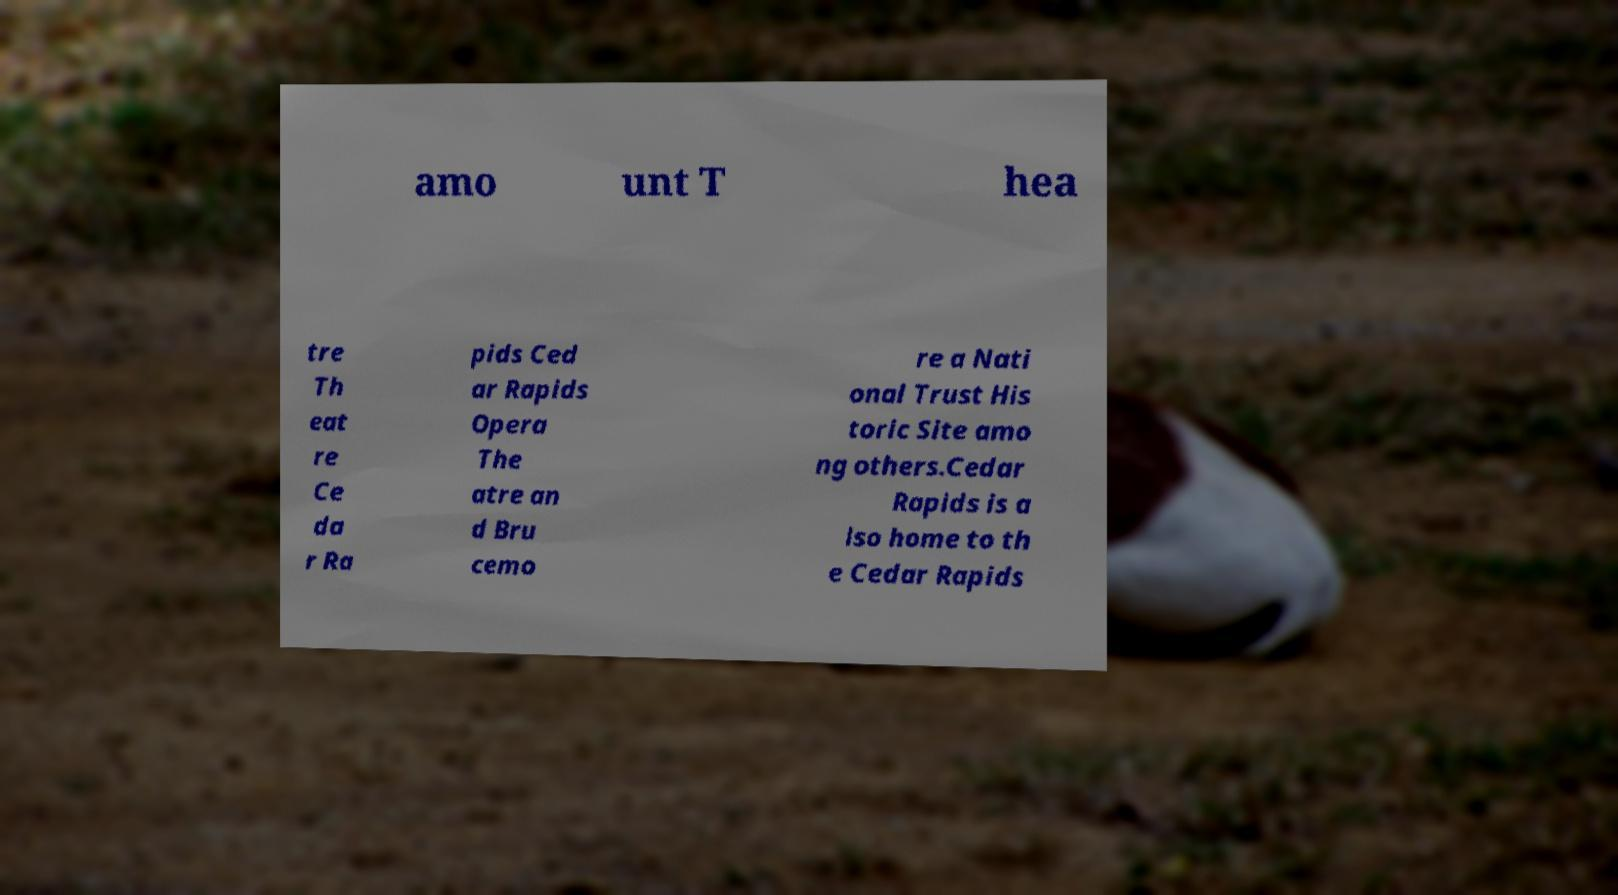What messages or text are displayed in this image? I need them in a readable, typed format. amo unt T hea tre Th eat re Ce da r Ra pids Ced ar Rapids Opera The atre an d Bru cemo re a Nati onal Trust His toric Site amo ng others.Cedar Rapids is a lso home to th e Cedar Rapids 